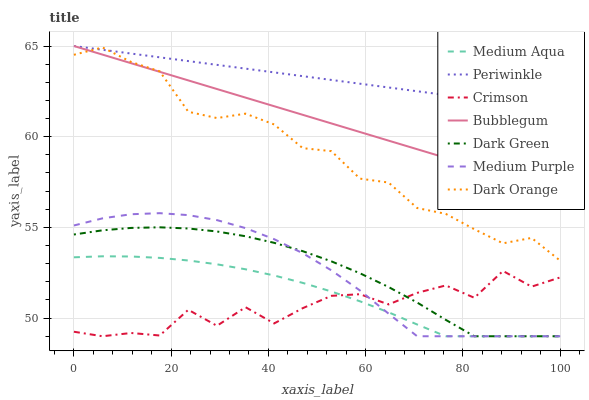Does Crimson have the minimum area under the curve?
Answer yes or no. Yes. Does Periwinkle have the maximum area under the curve?
Answer yes or no. Yes. Does Bubblegum have the minimum area under the curve?
Answer yes or no. No. Does Bubblegum have the maximum area under the curve?
Answer yes or no. No. Is Periwinkle the smoothest?
Answer yes or no. Yes. Is Crimson the roughest?
Answer yes or no. Yes. Is Bubblegum the smoothest?
Answer yes or no. No. Is Bubblegum the roughest?
Answer yes or no. No. Does Medium Purple have the lowest value?
Answer yes or no. Yes. Does Bubblegum have the lowest value?
Answer yes or no. No. Does Periwinkle have the highest value?
Answer yes or no. Yes. Does Medium Purple have the highest value?
Answer yes or no. No. Is Medium Aqua less than Bubblegum?
Answer yes or no. Yes. Is Dark Orange greater than Medium Aqua?
Answer yes or no. Yes. Does Dark Green intersect Medium Purple?
Answer yes or no. Yes. Is Dark Green less than Medium Purple?
Answer yes or no. No. Is Dark Green greater than Medium Purple?
Answer yes or no. No. Does Medium Aqua intersect Bubblegum?
Answer yes or no. No. 